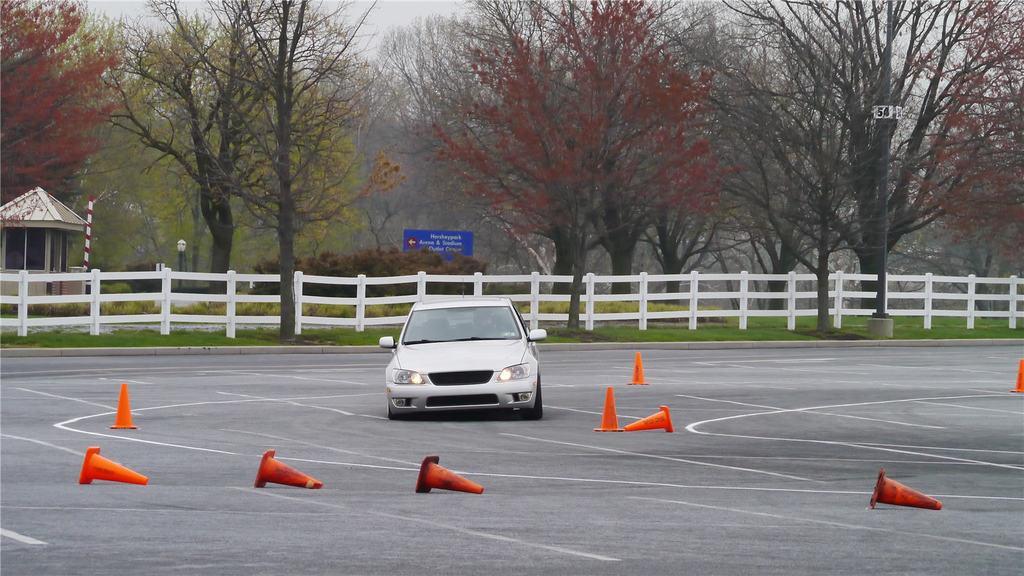Can you describe this image briefly? In this image I can see a road in the centre and on it I can see few orange colored traffic cones and a car. In the background I can see number of trees, grass, a blue colour board and on it I can see something is written. On the left side of this image I can see a pole and a shack. 